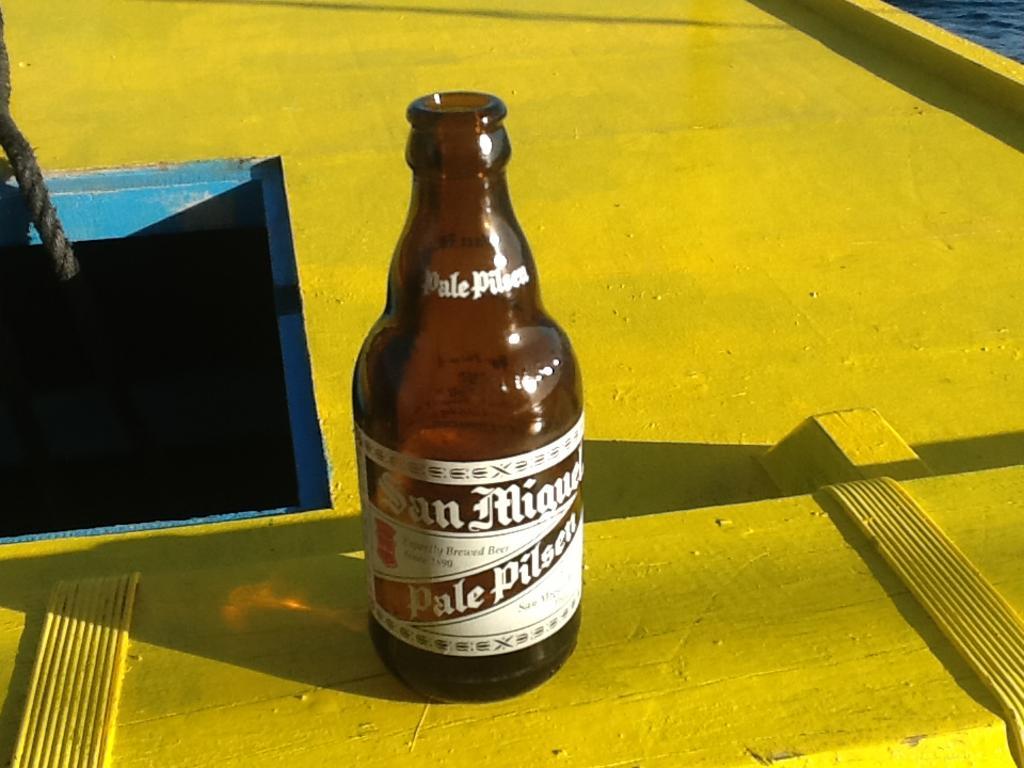Could you give a brief overview of what you see in this image? The image is taken on the deck. In the center of the image there is a bottle. This is a brown color bottle behind the bottle there is a pit and there is a rope hanging from the pit. 